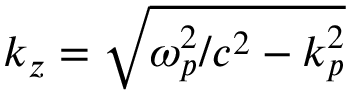<formula> <loc_0><loc_0><loc_500><loc_500>k _ { z } = \sqrt { \omega _ { p } ^ { 2 } / c ^ { 2 } - k _ { p } ^ { 2 } }</formula> 